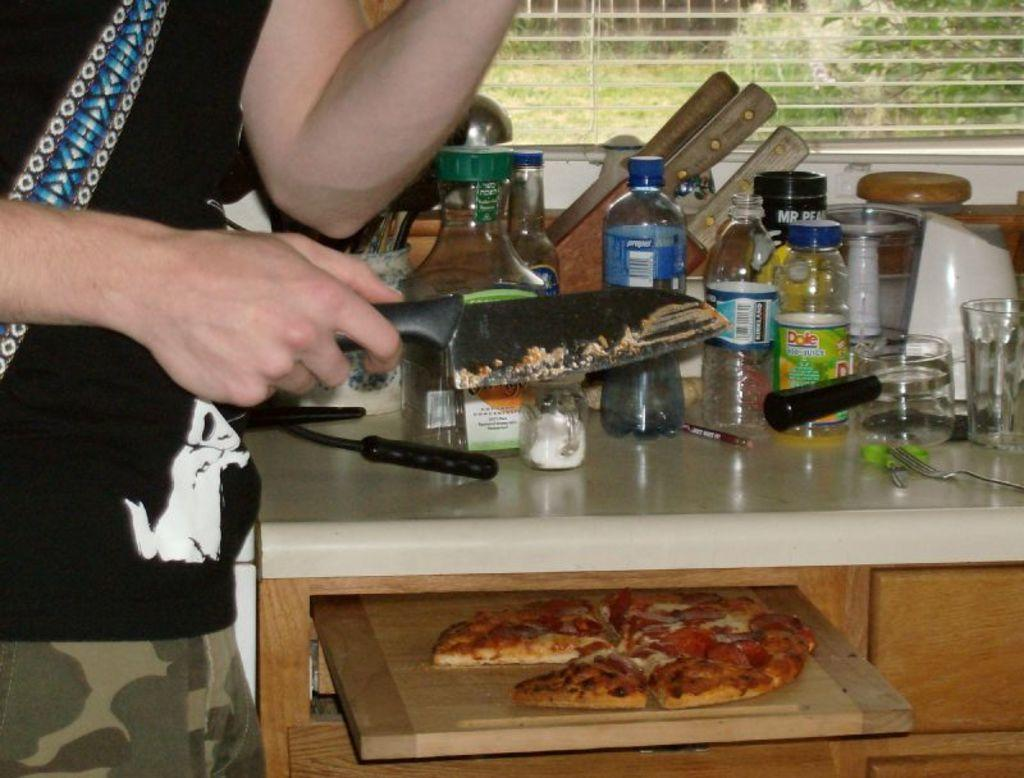<image>
Relay a brief, clear account of the picture shown. A person is cutting a pizza on a cutting board by some Dole juice. 